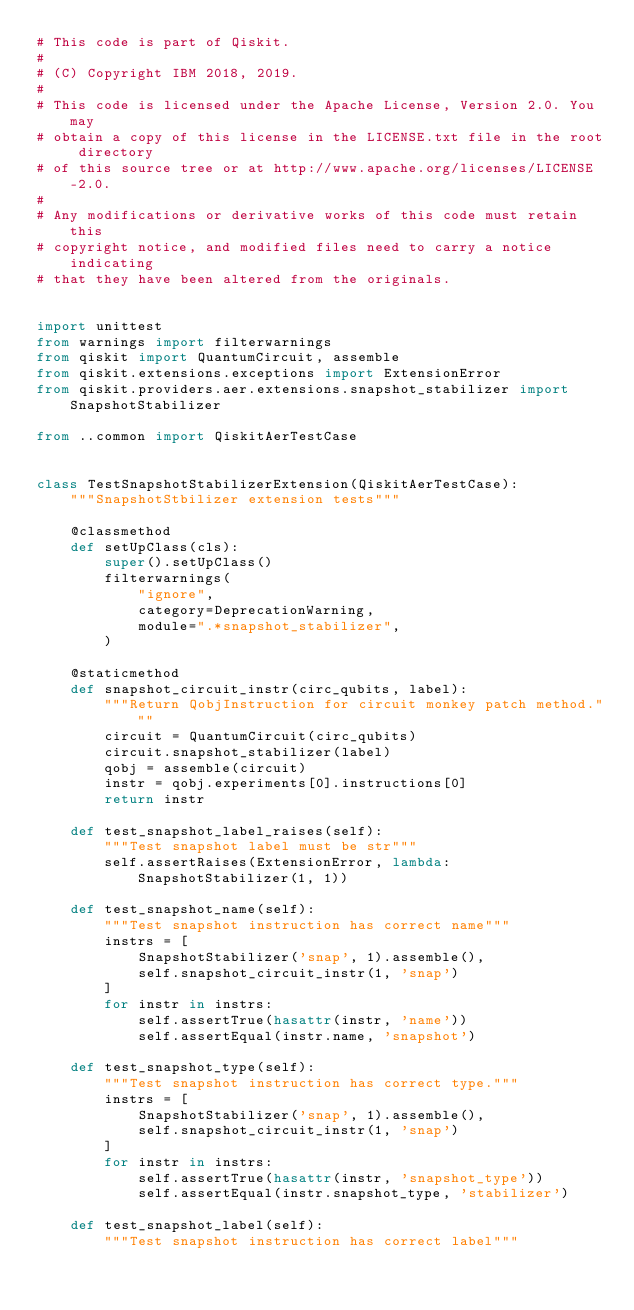<code> <loc_0><loc_0><loc_500><loc_500><_Python_># This code is part of Qiskit.
#
# (C) Copyright IBM 2018, 2019.
#
# This code is licensed under the Apache License, Version 2.0. You may
# obtain a copy of this license in the LICENSE.txt file in the root directory
# of this source tree or at http://www.apache.org/licenses/LICENSE-2.0.
#
# Any modifications or derivative works of this code must retain this
# copyright notice, and modified files need to carry a notice indicating
# that they have been altered from the originals.


import unittest
from warnings import filterwarnings
from qiskit import QuantumCircuit, assemble
from qiskit.extensions.exceptions import ExtensionError
from qiskit.providers.aer.extensions.snapshot_stabilizer import SnapshotStabilizer

from ..common import QiskitAerTestCase


class TestSnapshotStabilizerExtension(QiskitAerTestCase):
    """SnapshotStbilizer extension tests"""

    @classmethod
    def setUpClass(cls):
        super().setUpClass()
        filterwarnings(
            "ignore",
            category=DeprecationWarning,
            module=".*snapshot_stabilizer",
        )

    @staticmethod
    def snapshot_circuit_instr(circ_qubits, label):
        """Return QobjInstruction for circuit monkey patch method."""
        circuit = QuantumCircuit(circ_qubits)
        circuit.snapshot_stabilizer(label)
        qobj = assemble(circuit)
        instr = qobj.experiments[0].instructions[0]
        return instr

    def test_snapshot_label_raises(self):
        """Test snapshot label must be str"""
        self.assertRaises(ExtensionError, lambda: SnapshotStabilizer(1, 1))

    def test_snapshot_name(self):
        """Test snapshot instruction has correct name"""
        instrs = [
            SnapshotStabilizer('snap', 1).assemble(),
            self.snapshot_circuit_instr(1, 'snap')
        ]
        for instr in instrs:
            self.assertTrue(hasattr(instr, 'name'))
            self.assertEqual(instr.name, 'snapshot')

    def test_snapshot_type(self):
        """Test snapshot instruction has correct type."""
        instrs = [
            SnapshotStabilizer('snap', 1).assemble(),
            self.snapshot_circuit_instr(1, 'snap')
        ]
        for instr in instrs:
            self.assertTrue(hasattr(instr, 'snapshot_type'))
            self.assertEqual(instr.snapshot_type, 'stabilizer')

    def test_snapshot_label(self):
        """Test snapshot instruction has correct label"""</code> 